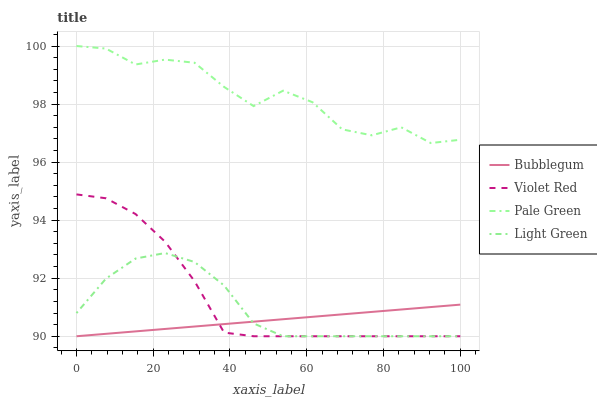Does Bubblegum have the minimum area under the curve?
Answer yes or no. Yes. Does Pale Green have the maximum area under the curve?
Answer yes or no. Yes. Does Light Green have the minimum area under the curve?
Answer yes or no. No. Does Light Green have the maximum area under the curve?
Answer yes or no. No. Is Bubblegum the smoothest?
Answer yes or no. Yes. Is Pale Green the roughest?
Answer yes or no. Yes. Is Light Green the smoothest?
Answer yes or no. No. Is Light Green the roughest?
Answer yes or no. No. Does Violet Red have the lowest value?
Answer yes or no. Yes. Does Pale Green have the lowest value?
Answer yes or no. No. Does Pale Green have the highest value?
Answer yes or no. Yes. Does Light Green have the highest value?
Answer yes or no. No. Is Light Green less than Pale Green?
Answer yes or no. Yes. Is Pale Green greater than Bubblegum?
Answer yes or no. Yes. Does Violet Red intersect Light Green?
Answer yes or no. Yes. Is Violet Red less than Light Green?
Answer yes or no. No. Is Violet Red greater than Light Green?
Answer yes or no. No. Does Light Green intersect Pale Green?
Answer yes or no. No. 